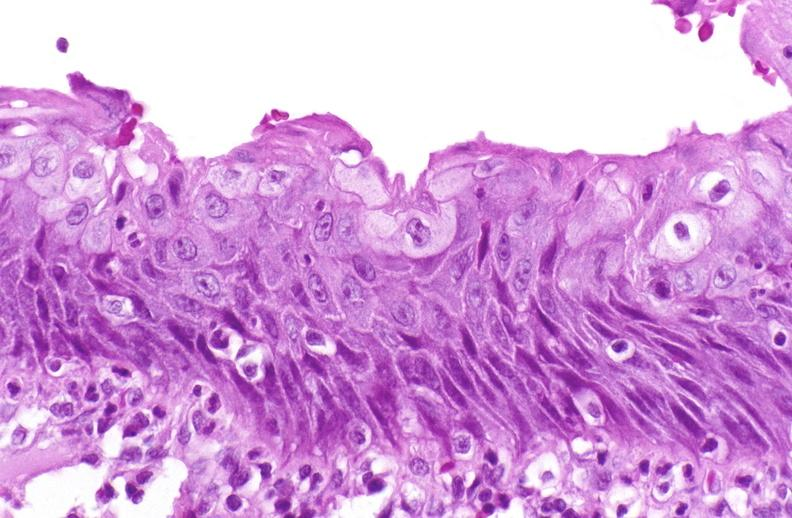s urinary present?
Answer the question using a single word or phrase. Yes 